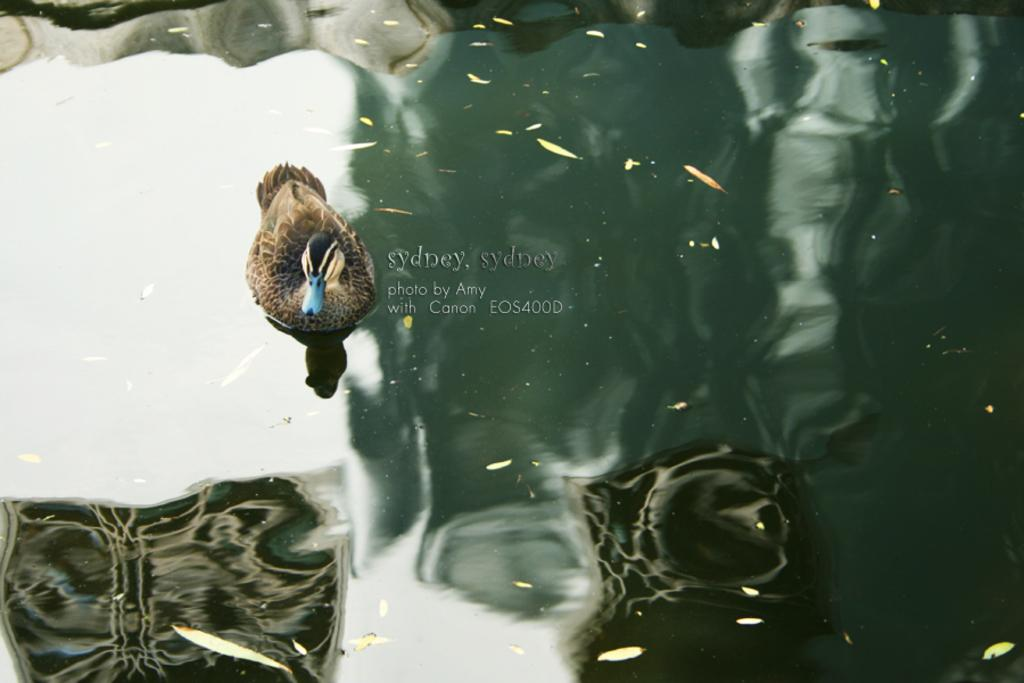What type of animal is in the image? There is a bird in the image. Where is the bird located? The bird is on the water. What colors can be seen on the bird? The bird has brown, black, and blue colors. What can be seen in the water besides the bird? The reflection of the sky is visible in the water. What type of lizards can be seen swimming in the water with the bird? There are no lizards present in the image; it features a bird on the water. What is your opinion on the bird's choice of color? The conversation does not involve expressing opinions, as we are focusing on providing factual information about the image. 